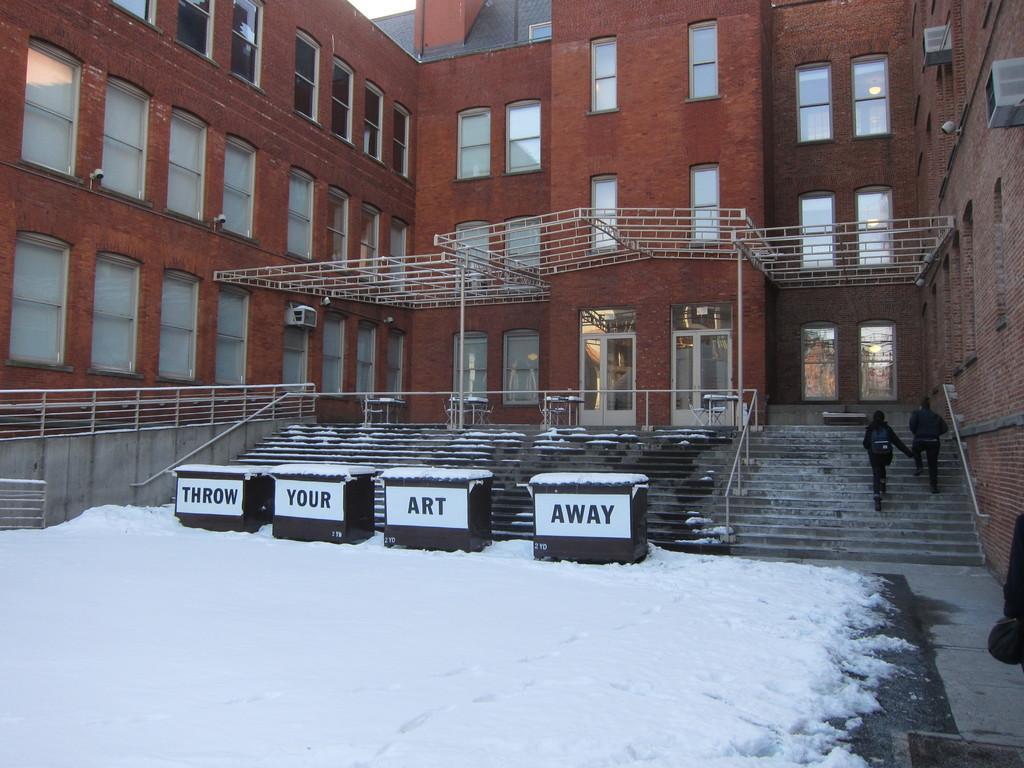Could you give a brief overview of what you see in this image? In this picture we can see boxes on snow with some text on it, two people walking on steps, railings, building with windows and some objects. 